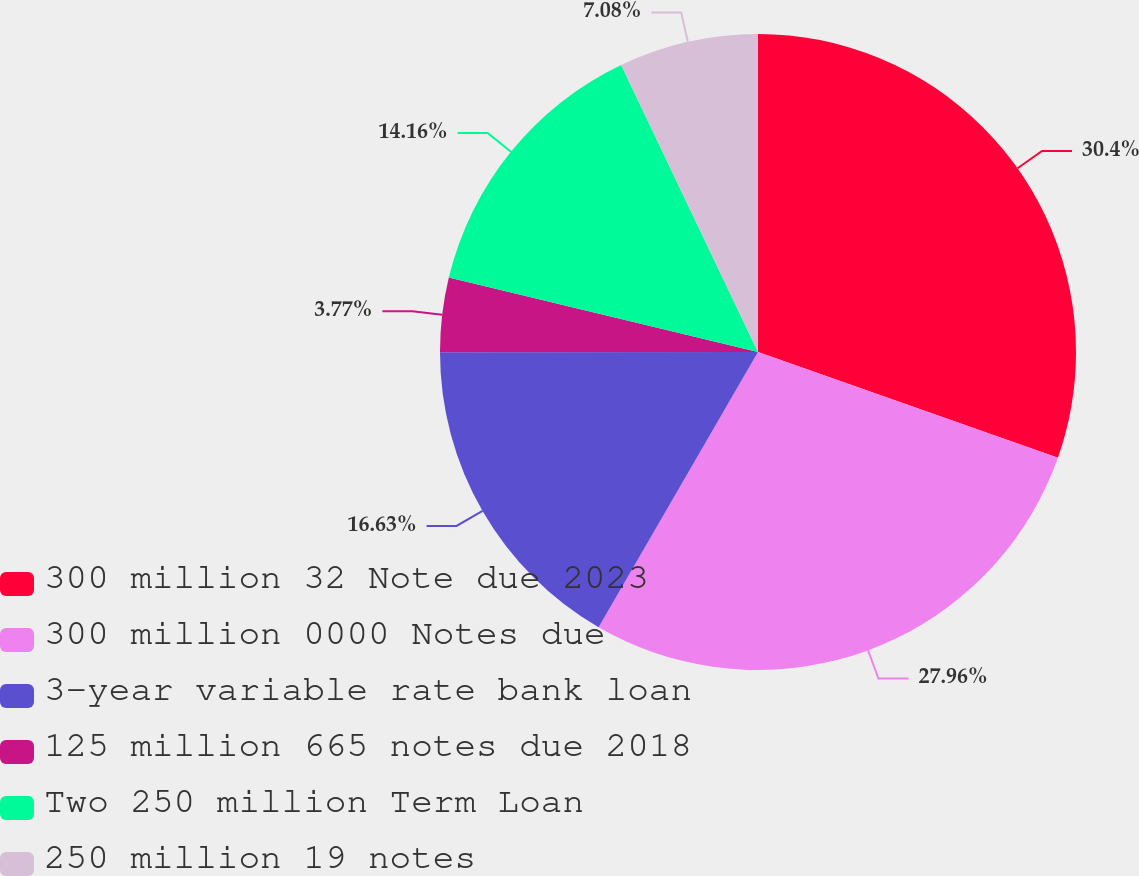Convert chart. <chart><loc_0><loc_0><loc_500><loc_500><pie_chart><fcel>300 million 32 Note due 2023<fcel>300 million 0000 Notes due<fcel>3-year variable rate bank loan<fcel>125 million 665 notes due 2018<fcel>Two 250 million Term Loan<fcel>250 million 19 notes<nl><fcel>30.39%<fcel>27.96%<fcel>16.63%<fcel>3.77%<fcel>14.16%<fcel>7.08%<nl></chart> 